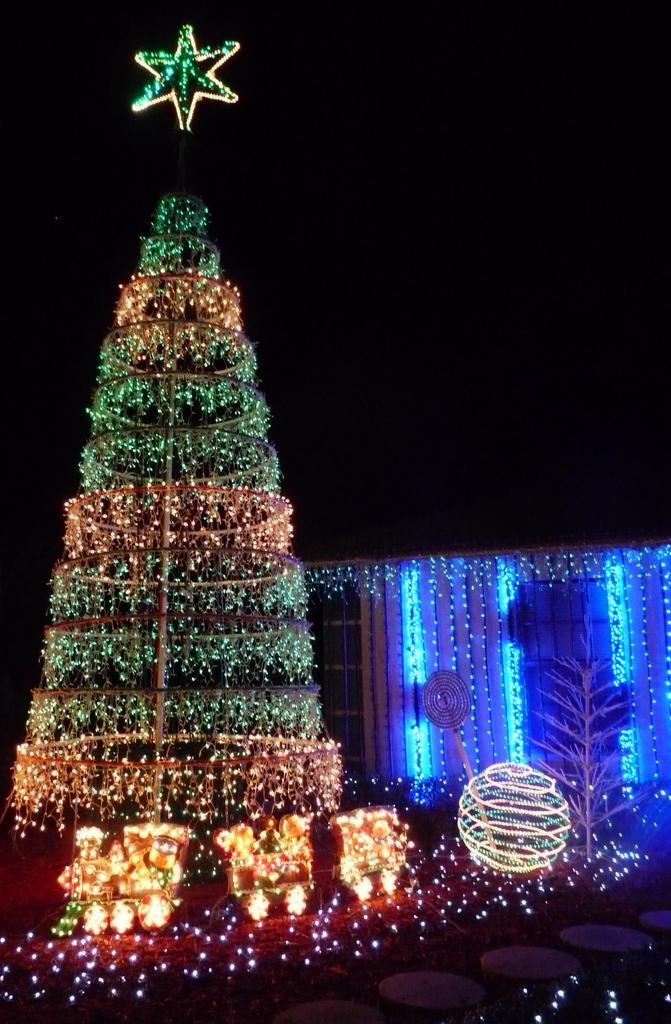How would you summarize this image in a sentence or two? On the left side of the image we can see an xmas tree decorated with lights. At the bottom there are decorations. In the background there is a building. 